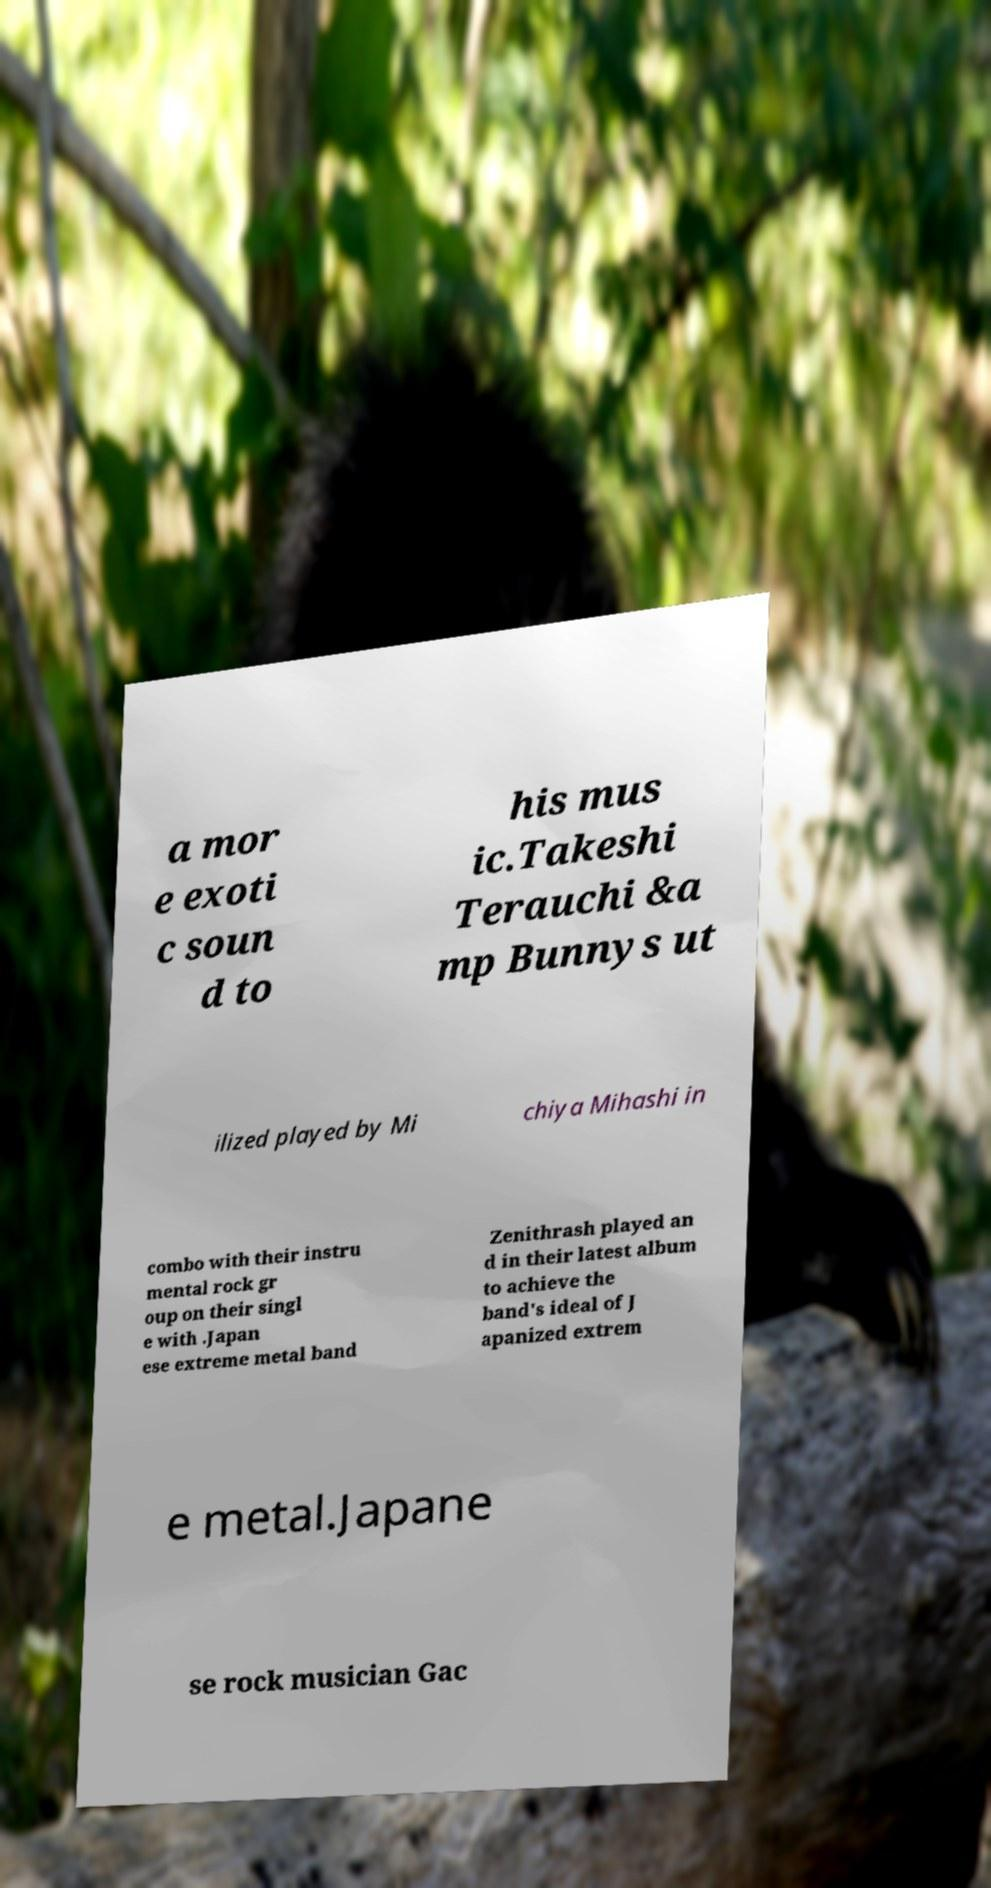Could you extract and type out the text from this image? a mor e exoti c soun d to his mus ic.Takeshi Terauchi &a mp Bunnys ut ilized played by Mi chiya Mihashi in combo with their instru mental rock gr oup on their singl e with .Japan ese extreme metal band Zenithrash played an d in their latest album to achieve the band's ideal of J apanized extrem e metal.Japane se rock musician Gac 